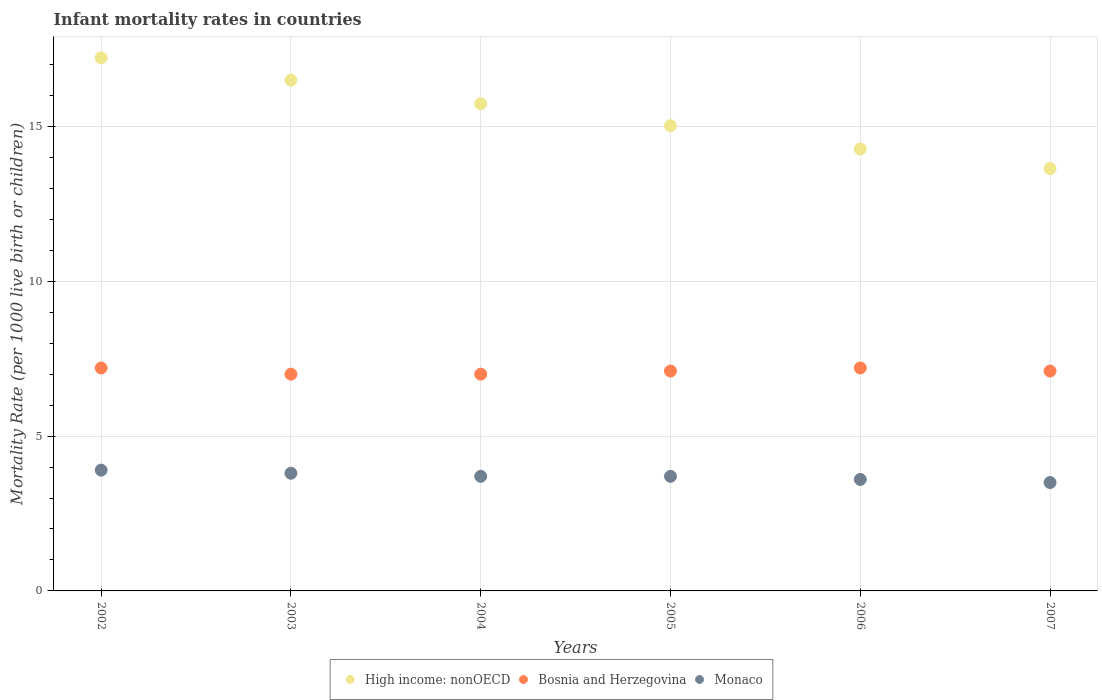What is the infant mortality rate in Bosnia and Herzegovina in 2002?
Offer a very short reply. 7.2. Across all years, what is the minimum infant mortality rate in Bosnia and Herzegovina?
Your response must be concise. 7. In which year was the infant mortality rate in High income: nonOECD maximum?
Give a very brief answer. 2002. In which year was the infant mortality rate in Monaco minimum?
Provide a succinct answer. 2007. What is the total infant mortality rate in High income: nonOECD in the graph?
Your answer should be compact. 92.36. What is the difference between the infant mortality rate in Bosnia and Herzegovina in 2003 and that in 2004?
Ensure brevity in your answer.  0. What is the difference between the infant mortality rate in Monaco in 2003 and the infant mortality rate in Bosnia and Herzegovina in 2007?
Provide a succinct answer. -3.3. What is the average infant mortality rate in Bosnia and Herzegovina per year?
Your answer should be very brief. 7.1. In the year 2005, what is the difference between the infant mortality rate in Bosnia and Herzegovina and infant mortality rate in Monaco?
Offer a very short reply. 3.4. What is the ratio of the infant mortality rate in High income: nonOECD in 2003 to that in 2004?
Ensure brevity in your answer.  1.05. What is the difference between the highest and the second highest infant mortality rate in Monaco?
Make the answer very short. 0.1. What is the difference between the highest and the lowest infant mortality rate in High income: nonOECD?
Your answer should be very brief. 3.58. In how many years, is the infant mortality rate in Monaco greater than the average infant mortality rate in Monaco taken over all years?
Provide a succinct answer. 4. Is the sum of the infant mortality rate in Bosnia and Herzegovina in 2002 and 2004 greater than the maximum infant mortality rate in Monaco across all years?
Make the answer very short. Yes. Does the infant mortality rate in Bosnia and Herzegovina monotonically increase over the years?
Keep it short and to the point. No. How many dotlines are there?
Ensure brevity in your answer.  3. What is the difference between two consecutive major ticks on the Y-axis?
Keep it short and to the point. 5. Are the values on the major ticks of Y-axis written in scientific E-notation?
Make the answer very short. No. Does the graph contain grids?
Offer a terse response. Yes. How many legend labels are there?
Give a very brief answer. 3. What is the title of the graph?
Offer a terse response. Infant mortality rates in countries. Does "Moldova" appear as one of the legend labels in the graph?
Your answer should be very brief. No. What is the label or title of the X-axis?
Give a very brief answer. Years. What is the label or title of the Y-axis?
Offer a terse response. Mortality Rate (per 1000 live birth or children). What is the Mortality Rate (per 1000 live birth or children) of High income: nonOECD in 2002?
Offer a very short reply. 17.21. What is the Mortality Rate (per 1000 live birth or children) of Monaco in 2002?
Your answer should be compact. 3.9. What is the Mortality Rate (per 1000 live birth or children) of High income: nonOECD in 2003?
Offer a very short reply. 16.49. What is the Mortality Rate (per 1000 live birth or children) in Bosnia and Herzegovina in 2003?
Keep it short and to the point. 7. What is the Mortality Rate (per 1000 live birth or children) of High income: nonOECD in 2004?
Make the answer very short. 15.73. What is the Mortality Rate (per 1000 live birth or children) in Bosnia and Herzegovina in 2004?
Offer a terse response. 7. What is the Mortality Rate (per 1000 live birth or children) of Monaco in 2004?
Provide a succinct answer. 3.7. What is the Mortality Rate (per 1000 live birth or children) in High income: nonOECD in 2005?
Make the answer very short. 15.02. What is the Mortality Rate (per 1000 live birth or children) in High income: nonOECD in 2006?
Your response must be concise. 14.27. What is the Mortality Rate (per 1000 live birth or children) in Bosnia and Herzegovina in 2006?
Your response must be concise. 7.2. What is the Mortality Rate (per 1000 live birth or children) of High income: nonOECD in 2007?
Provide a short and direct response. 13.64. What is the Mortality Rate (per 1000 live birth or children) in Monaco in 2007?
Offer a terse response. 3.5. Across all years, what is the maximum Mortality Rate (per 1000 live birth or children) in High income: nonOECD?
Your response must be concise. 17.21. Across all years, what is the maximum Mortality Rate (per 1000 live birth or children) in Monaco?
Keep it short and to the point. 3.9. Across all years, what is the minimum Mortality Rate (per 1000 live birth or children) in High income: nonOECD?
Give a very brief answer. 13.64. Across all years, what is the minimum Mortality Rate (per 1000 live birth or children) of Bosnia and Herzegovina?
Offer a terse response. 7. What is the total Mortality Rate (per 1000 live birth or children) in High income: nonOECD in the graph?
Give a very brief answer. 92.36. What is the total Mortality Rate (per 1000 live birth or children) of Bosnia and Herzegovina in the graph?
Ensure brevity in your answer.  42.6. What is the total Mortality Rate (per 1000 live birth or children) of Monaco in the graph?
Provide a succinct answer. 22.2. What is the difference between the Mortality Rate (per 1000 live birth or children) in High income: nonOECD in 2002 and that in 2003?
Your answer should be very brief. 0.72. What is the difference between the Mortality Rate (per 1000 live birth or children) in High income: nonOECD in 2002 and that in 2004?
Your response must be concise. 1.48. What is the difference between the Mortality Rate (per 1000 live birth or children) of Monaco in 2002 and that in 2004?
Ensure brevity in your answer.  0.2. What is the difference between the Mortality Rate (per 1000 live birth or children) in High income: nonOECD in 2002 and that in 2005?
Your response must be concise. 2.2. What is the difference between the Mortality Rate (per 1000 live birth or children) of Bosnia and Herzegovina in 2002 and that in 2005?
Offer a very short reply. 0.1. What is the difference between the Mortality Rate (per 1000 live birth or children) of High income: nonOECD in 2002 and that in 2006?
Keep it short and to the point. 2.95. What is the difference between the Mortality Rate (per 1000 live birth or children) of Monaco in 2002 and that in 2006?
Give a very brief answer. 0.3. What is the difference between the Mortality Rate (per 1000 live birth or children) of High income: nonOECD in 2002 and that in 2007?
Give a very brief answer. 3.58. What is the difference between the Mortality Rate (per 1000 live birth or children) of Bosnia and Herzegovina in 2002 and that in 2007?
Provide a succinct answer. 0.1. What is the difference between the Mortality Rate (per 1000 live birth or children) of High income: nonOECD in 2003 and that in 2004?
Give a very brief answer. 0.76. What is the difference between the Mortality Rate (per 1000 live birth or children) in Monaco in 2003 and that in 2004?
Provide a succinct answer. 0.1. What is the difference between the Mortality Rate (per 1000 live birth or children) of High income: nonOECD in 2003 and that in 2005?
Keep it short and to the point. 1.47. What is the difference between the Mortality Rate (per 1000 live birth or children) in Bosnia and Herzegovina in 2003 and that in 2005?
Provide a succinct answer. -0.1. What is the difference between the Mortality Rate (per 1000 live birth or children) in High income: nonOECD in 2003 and that in 2006?
Your answer should be very brief. 2.23. What is the difference between the Mortality Rate (per 1000 live birth or children) of Bosnia and Herzegovina in 2003 and that in 2006?
Ensure brevity in your answer.  -0.2. What is the difference between the Mortality Rate (per 1000 live birth or children) in High income: nonOECD in 2003 and that in 2007?
Your response must be concise. 2.85. What is the difference between the Mortality Rate (per 1000 live birth or children) of High income: nonOECD in 2004 and that in 2005?
Provide a succinct answer. 0.71. What is the difference between the Mortality Rate (per 1000 live birth or children) of Bosnia and Herzegovina in 2004 and that in 2005?
Your answer should be very brief. -0.1. What is the difference between the Mortality Rate (per 1000 live birth or children) in Monaco in 2004 and that in 2005?
Keep it short and to the point. 0. What is the difference between the Mortality Rate (per 1000 live birth or children) in High income: nonOECD in 2004 and that in 2006?
Ensure brevity in your answer.  1.46. What is the difference between the Mortality Rate (per 1000 live birth or children) in Monaco in 2004 and that in 2006?
Your answer should be compact. 0.1. What is the difference between the Mortality Rate (per 1000 live birth or children) of High income: nonOECD in 2004 and that in 2007?
Offer a terse response. 2.09. What is the difference between the Mortality Rate (per 1000 live birth or children) in Monaco in 2004 and that in 2007?
Provide a succinct answer. 0.2. What is the difference between the Mortality Rate (per 1000 live birth or children) of High income: nonOECD in 2005 and that in 2006?
Make the answer very short. 0.75. What is the difference between the Mortality Rate (per 1000 live birth or children) of Bosnia and Herzegovina in 2005 and that in 2006?
Offer a very short reply. -0.1. What is the difference between the Mortality Rate (per 1000 live birth or children) in Monaco in 2005 and that in 2006?
Your answer should be very brief. 0.1. What is the difference between the Mortality Rate (per 1000 live birth or children) of High income: nonOECD in 2005 and that in 2007?
Provide a succinct answer. 1.38. What is the difference between the Mortality Rate (per 1000 live birth or children) of Bosnia and Herzegovina in 2005 and that in 2007?
Your answer should be compact. 0. What is the difference between the Mortality Rate (per 1000 live birth or children) in Monaco in 2005 and that in 2007?
Make the answer very short. 0.2. What is the difference between the Mortality Rate (per 1000 live birth or children) in High income: nonOECD in 2006 and that in 2007?
Keep it short and to the point. 0.63. What is the difference between the Mortality Rate (per 1000 live birth or children) of High income: nonOECD in 2002 and the Mortality Rate (per 1000 live birth or children) of Bosnia and Herzegovina in 2003?
Offer a terse response. 10.21. What is the difference between the Mortality Rate (per 1000 live birth or children) in High income: nonOECD in 2002 and the Mortality Rate (per 1000 live birth or children) in Monaco in 2003?
Keep it short and to the point. 13.41. What is the difference between the Mortality Rate (per 1000 live birth or children) of High income: nonOECD in 2002 and the Mortality Rate (per 1000 live birth or children) of Bosnia and Herzegovina in 2004?
Keep it short and to the point. 10.21. What is the difference between the Mortality Rate (per 1000 live birth or children) of High income: nonOECD in 2002 and the Mortality Rate (per 1000 live birth or children) of Monaco in 2004?
Your answer should be compact. 13.51. What is the difference between the Mortality Rate (per 1000 live birth or children) in Bosnia and Herzegovina in 2002 and the Mortality Rate (per 1000 live birth or children) in Monaco in 2004?
Give a very brief answer. 3.5. What is the difference between the Mortality Rate (per 1000 live birth or children) in High income: nonOECD in 2002 and the Mortality Rate (per 1000 live birth or children) in Bosnia and Herzegovina in 2005?
Provide a short and direct response. 10.11. What is the difference between the Mortality Rate (per 1000 live birth or children) in High income: nonOECD in 2002 and the Mortality Rate (per 1000 live birth or children) in Monaco in 2005?
Your answer should be compact. 13.51. What is the difference between the Mortality Rate (per 1000 live birth or children) in High income: nonOECD in 2002 and the Mortality Rate (per 1000 live birth or children) in Bosnia and Herzegovina in 2006?
Ensure brevity in your answer.  10.01. What is the difference between the Mortality Rate (per 1000 live birth or children) in High income: nonOECD in 2002 and the Mortality Rate (per 1000 live birth or children) in Monaco in 2006?
Offer a very short reply. 13.61. What is the difference between the Mortality Rate (per 1000 live birth or children) of High income: nonOECD in 2002 and the Mortality Rate (per 1000 live birth or children) of Bosnia and Herzegovina in 2007?
Keep it short and to the point. 10.11. What is the difference between the Mortality Rate (per 1000 live birth or children) of High income: nonOECD in 2002 and the Mortality Rate (per 1000 live birth or children) of Monaco in 2007?
Keep it short and to the point. 13.71. What is the difference between the Mortality Rate (per 1000 live birth or children) in High income: nonOECD in 2003 and the Mortality Rate (per 1000 live birth or children) in Bosnia and Herzegovina in 2004?
Keep it short and to the point. 9.49. What is the difference between the Mortality Rate (per 1000 live birth or children) of High income: nonOECD in 2003 and the Mortality Rate (per 1000 live birth or children) of Monaco in 2004?
Your response must be concise. 12.79. What is the difference between the Mortality Rate (per 1000 live birth or children) in High income: nonOECD in 2003 and the Mortality Rate (per 1000 live birth or children) in Bosnia and Herzegovina in 2005?
Ensure brevity in your answer.  9.39. What is the difference between the Mortality Rate (per 1000 live birth or children) in High income: nonOECD in 2003 and the Mortality Rate (per 1000 live birth or children) in Monaco in 2005?
Your answer should be very brief. 12.79. What is the difference between the Mortality Rate (per 1000 live birth or children) in Bosnia and Herzegovina in 2003 and the Mortality Rate (per 1000 live birth or children) in Monaco in 2005?
Ensure brevity in your answer.  3.3. What is the difference between the Mortality Rate (per 1000 live birth or children) of High income: nonOECD in 2003 and the Mortality Rate (per 1000 live birth or children) of Bosnia and Herzegovina in 2006?
Offer a very short reply. 9.29. What is the difference between the Mortality Rate (per 1000 live birth or children) in High income: nonOECD in 2003 and the Mortality Rate (per 1000 live birth or children) in Monaco in 2006?
Your answer should be compact. 12.89. What is the difference between the Mortality Rate (per 1000 live birth or children) of Bosnia and Herzegovina in 2003 and the Mortality Rate (per 1000 live birth or children) of Monaco in 2006?
Offer a very short reply. 3.4. What is the difference between the Mortality Rate (per 1000 live birth or children) in High income: nonOECD in 2003 and the Mortality Rate (per 1000 live birth or children) in Bosnia and Herzegovina in 2007?
Your answer should be very brief. 9.39. What is the difference between the Mortality Rate (per 1000 live birth or children) in High income: nonOECD in 2003 and the Mortality Rate (per 1000 live birth or children) in Monaco in 2007?
Offer a very short reply. 12.99. What is the difference between the Mortality Rate (per 1000 live birth or children) in High income: nonOECD in 2004 and the Mortality Rate (per 1000 live birth or children) in Bosnia and Herzegovina in 2005?
Your answer should be compact. 8.63. What is the difference between the Mortality Rate (per 1000 live birth or children) in High income: nonOECD in 2004 and the Mortality Rate (per 1000 live birth or children) in Monaco in 2005?
Provide a short and direct response. 12.03. What is the difference between the Mortality Rate (per 1000 live birth or children) in Bosnia and Herzegovina in 2004 and the Mortality Rate (per 1000 live birth or children) in Monaco in 2005?
Provide a succinct answer. 3.3. What is the difference between the Mortality Rate (per 1000 live birth or children) in High income: nonOECD in 2004 and the Mortality Rate (per 1000 live birth or children) in Bosnia and Herzegovina in 2006?
Ensure brevity in your answer.  8.53. What is the difference between the Mortality Rate (per 1000 live birth or children) of High income: nonOECD in 2004 and the Mortality Rate (per 1000 live birth or children) of Monaco in 2006?
Ensure brevity in your answer.  12.13. What is the difference between the Mortality Rate (per 1000 live birth or children) in High income: nonOECD in 2004 and the Mortality Rate (per 1000 live birth or children) in Bosnia and Herzegovina in 2007?
Offer a terse response. 8.63. What is the difference between the Mortality Rate (per 1000 live birth or children) in High income: nonOECD in 2004 and the Mortality Rate (per 1000 live birth or children) in Monaco in 2007?
Offer a terse response. 12.23. What is the difference between the Mortality Rate (per 1000 live birth or children) of Bosnia and Herzegovina in 2004 and the Mortality Rate (per 1000 live birth or children) of Monaco in 2007?
Ensure brevity in your answer.  3.5. What is the difference between the Mortality Rate (per 1000 live birth or children) in High income: nonOECD in 2005 and the Mortality Rate (per 1000 live birth or children) in Bosnia and Herzegovina in 2006?
Provide a short and direct response. 7.82. What is the difference between the Mortality Rate (per 1000 live birth or children) in High income: nonOECD in 2005 and the Mortality Rate (per 1000 live birth or children) in Monaco in 2006?
Offer a terse response. 11.42. What is the difference between the Mortality Rate (per 1000 live birth or children) of Bosnia and Herzegovina in 2005 and the Mortality Rate (per 1000 live birth or children) of Monaco in 2006?
Keep it short and to the point. 3.5. What is the difference between the Mortality Rate (per 1000 live birth or children) in High income: nonOECD in 2005 and the Mortality Rate (per 1000 live birth or children) in Bosnia and Herzegovina in 2007?
Your answer should be very brief. 7.92. What is the difference between the Mortality Rate (per 1000 live birth or children) in High income: nonOECD in 2005 and the Mortality Rate (per 1000 live birth or children) in Monaco in 2007?
Make the answer very short. 11.52. What is the difference between the Mortality Rate (per 1000 live birth or children) of Bosnia and Herzegovina in 2005 and the Mortality Rate (per 1000 live birth or children) of Monaco in 2007?
Offer a very short reply. 3.6. What is the difference between the Mortality Rate (per 1000 live birth or children) in High income: nonOECD in 2006 and the Mortality Rate (per 1000 live birth or children) in Bosnia and Herzegovina in 2007?
Offer a very short reply. 7.17. What is the difference between the Mortality Rate (per 1000 live birth or children) in High income: nonOECD in 2006 and the Mortality Rate (per 1000 live birth or children) in Monaco in 2007?
Give a very brief answer. 10.77. What is the difference between the Mortality Rate (per 1000 live birth or children) in Bosnia and Herzegovina in 2006 and the Mortality Rate (per 1000 live birth or children) in Monaco in 2007?
Provide a short and direct response. 3.7. What is the average Mortality Rate (per 1000 live birth or children) of High income: nonOECD per year?
Offer a very short reply. 15.39. What is the average Mortality Rate (per 1000 live birth or children) in Monaco per year?
Offer a very short reply. 3.7. In the year 2002, what is the difference between the Mortality Rate (per 1000 live birth or children) of High income: nonOECD and Mortality Rate (per 1000 live birth or children) of Bosnia and Herzegovina?
Your answer should be very brief. 10.01. In the year 2002, what is the difference between the Mortality Rate (per 1000 live birth or children) of High income: nonOECD and Mortality Rate (per 1000 live birth or children) of Monaco?
Provide a short and direct response. 13.31. In the year 2002, what is the difference between the Mortality Rate (per 1000 live birth or children) of Bosnia and Herzegovina and Mortality Rate (per 1000 live birth or children) of Monaco?
Offer a very short reply. 3.3. In the year 2003, what is the difference between the Mortality Rate (per 1000 live birth or children) in High income: nonOECD and Mortality Rate (per 1000 live birth or children) in Bosnia and Herzegovina?
Ensure brevity in your answer.  9.49. In the year 2003, what is the difference between the Mortality Rate (per 1000 live birth or children) in High income: nonOECD and Mortality Rate (per 1000 live birth or children) in Monaco?
Ensure brevity in your answer.  12.69. In the year 2003, what is the difference between the Mortality Rate (per 1000 live birth or children) in Bosnia and Herzegovina and Mortality Rate (per 1000 live birth or children) in Monaco?
Your answer should be very brief. 3.2. In the year 2004, what is the difference between the Mortality Rate (per 1000 live birth or children) in High income: nonOECD and Mortality Rate (per 1000 live birth or children) in Bosnia and Herzegovina?
Ensure brevity in your answer.  8.73. In the year 2004, what is the difference between the Mortality Rate (per 1000 live birth or children) in High income: nonOECD and Mortality Rate (per 1000 live birth or children) in Monaco?
Your response must be concise. 12.03. In the year 2004, what is the difference between the Mortality Rate (per 1000 live birth or children) in Bosnia and Herzegovina and Mortality Rate (per 1000 live birth or children) in Monaco?
Keep it short and to the point. 3.3. In the year 2005, what is the difference between the Mortality Rate (per 1000 live birth or children) in High income: nonOECD and Mortality Rate (per 1000 live birth or children) in Bosnia and Herzegovina?
Provide a short and direct response. 7.92. In the year 2005, what is the difference between the Mortality Rate (per 1000 live birth or children) in High income: nonOECD and Mortality Rate (per 1000 live birth or children) in Monaco?
Offer a very short reply. 11.32. In the year 2006, what is the difference between the Mortality Rate (per 1000 live birth or children) in High income: nonOECD and Mortality Rate (per 1000 live birth or children) in Bosnia and Herzegovina?
Keep it short and to the point. 7.07. In the year 2006, what is the difference between the Mortality Rate (per 1000 live birth or children) in High income: nonOECD and Mortality Rate (per 1000 live birth or children) in Monaco?
Your response must be concise. 10.67. In the year 2006, what is the difference between the Mortality Rate (per 1000 live birth or children) in Bosnia and Herzegovina and Mortality Rate (per 1000 live birth or children) in Monaco?
Provide a succinct answer. 3.6. In the year 2007, what is the difference between the Mortality Rate (per 1000 live birth or children) of High income: nonOECD and Mortality Rate (per 1000 live birth or children) of Bosnia and Herzegovina?
Offer a terse response. 6.54. In the year 2007, what is the difference between the Mortality Rate (per 1000 live birth or children) of High income: nonOECD and Mortality Rate (per 1000 live birth or children) of Monaco?
Ensure brevity in your answer.  10.14. In the year 2007, what is the difference between the Mortality Rate (per 1000 live birth or children) of Bosnia and Herzegovina and Mortality Rate (per 1000 live birth or children) of Monaco?
Keep it short and to the point. 3.6. What is the ratio of the Mortality Rate (per 1000 live birth or children) in High income: nonOECD in 2002 to that in 2003?
Give a very brief answer. 1.04. What is the ratio of the Mortality Rate (per 1000 live birth or children) of Bosnia and Herzegovina in 2002 to that in 2003?
Provide a succinct answer. 1.03. What is the ratio of the Mortality Rate (per 1000 live birth or children) of Monaco in 2002 to that in 2003?
Your answer should be very brief. 1.03. What is the ratio of the Mortality Rate (per 1000 live birth or children) in High income: nonOECD in 2002 to that in 2004?
Provide a short and direct response. 1.09. What is the ratio of the Mortality Rate (per 1000 live birth or children) in Bosnia and Herzegovina in 2002 to that in 2004?
Offer a terse response. 1.03. What is the ratio of the Mortality Rate (per 1000 live birth or children) in Monaco in 2002 to that in 2004?
Your response must be concise. 1.05. What is the ratio of the Mortality Rate (per 1000 live birth or children) in High income: nonOECD in 2002 to that in 2005?
Provide a short and direct response. 1.15. What is the ratio of the Mortality Rate (per 1000 live birth or children) of Bosnia and Herzegovina in 2002 to that in 2005?
Provide a succinct answer. 1.01. What is the ratio of the Mortality Rate (per 1000 live birth or children) of Monaco in 2002 to that in 2005?
Keep it short and to the point. 1.05. What is the ratio of the Mortality Rate (per 1000 live birth or children) of High income: nonOECD in 2002 to that in 2006?
Offer a terse response. 1.21. What is the ratio of the Mortality Rate (per 1000 live birth or children) of Monaco in 2002 to that in 2006?
Make the answer very short. 1.08. What is the ratio of the Mortality Rate (per 1000 live birth or children) in High income: nonOECD in 2002 to that in 2007?
Ensure brevity in your answer.  1.26. What is the ratio of the Mortality Rate (per 1000 live birth or children) of Bosnia and Herzegovina in 2002 to that in 2007?
Provide a succinct answer. 1.01. What is the ratio of the Mortality Rate (per 1000 live birth or children) in Monaco in 2002 to that in 2007?
Your response must be concise. 1.11. What is the ratio of the Mortality Rate (per 1000 live birth or children) of High income: nonOECD in 2003 to that in 2004?
Make the answer very short. 1.05. What is the ratio of the Mortality Rate (per 1000 live birth or children) in High income: nonOECD in 2003 to that in 2005?
Offer a very short reply. 1.1. What is the ratio of the Mortality Rate (per 1000 live birth or children) of Bosnia and Herzegovina in 2003 to that in 2005?
Offer a terse response. 0.99. What is the ratio of the Mortality Rate (per 1000 live birth or children) in High income: nonOECD in 2003 to that in 2006?
Provide a short and direct response. 1.16. What is the ratio of the Mortality Rate (per 1000 live birth or children) of Bosnia and Herzegovina in 2003 to that in 2006?
Ensure brevity in your answer.  0.97. What is the ratio of the Mortality Rate (per 1000 live birth or children) in Monaco in 2003 to that in 2006?
Your answer should be compact. 1.06. What is the ratio of the Mortality Rate (per 1000 live birth or children) of High income: nonOECD in 2003 to that in 2007?
Offer a very short reply. 1.21. What is the ratio of the Mortality Rate (per 1000 live birth or children) of Bosnia and Herzegovina in 2003 to that in 2007?
Give a very brief answer. 0.99. What is the ratio of the Mortality Rate (per 1000 live birth or children) of Monaco in 2003 to that in 2007?
Provide a succinct answer. 1.09. What is the ratio of the Mortality Rate (per 1000 live birth or children) in High income: nonOECD in 2004 to that in 2005?
Ensure brevity in your answer.  1.05. What is the ratio of the Mortality Rate (per 1000 live birth or children) of Bosnia and Herzegovina in 2004 to that in 2005?
Your answer should be very brief. 0.99. What is the ratio of the Mortality Rate (per 1000 live birth or children) of Monaco in 2004 to that in 2005?
Your answer should be very brief. 1. What is the ratio of the Mortality Rate (per 1000 live birth or children) of High income: nonOECD in 2004 to that in 2006?
Your answer should be compact. 1.1. What is the ratio of the Mortality Rate (per 1000 live birth or children) of Bosnia and Herzegovina in 2004 to that in 2006?
Offer a very short reply. 0.97. What is the ratio of the Mortality Rate (per 1000 live birth or children) of Monaco in 2004 to that in 2006?
Ensure brevity in your answer.  1.03. What is the ratio of the Mortality Rate (per 1000 live birth or children) of High income: nonOECD in 2004 to that in 2007?
Provide a succinct answer. 1.15. What is the ratio of the Mortality Rate (per 1000 live birth or children) of Bosnia and Herzegovina in 2004 to that in 2007?
Give a very brief answer. 0.99. What is the ratio of the Mortality Rate (per 1000 live birth or children) of Monaco in 2004 to that in 2007?
Ensure brevity in your answer.  1.06. What is the ratio of the Mortality Rate (per 1000 live birth or children) in High income: nonOECD in 2005 to that in 2006?
Give a very brief answer. 1.05. What is the ratio of the Mortality Rate (per 1000 live birth or children) of Bosnia and Herzegovina in 2005 to that in 2006?
Keep it short and to the point. 0.99. What is the ratio of the Mortality Rate (per 1000 live birth or children) of Monaco in 2005 to that in 2006?
Ensure brevity in your answer.  1.03. What is the ratio of the Mortality Rate (per 1000 live birth or children) of High income: nonOECD in 2005 to that in 2007?
Your response must be concise. 1.1. What is the ratio of the Mortality Rate (per 1000 live birth or children) of Bosnia and Herzegovina in 2005 to that in 2007?
Your response must be concise. 1. What is the ratio of the Mortality Rate (per 1000 live birth or children) in Monaco in 2005 to that in 2007?
Your answer should be very brief. 1.06. What is the ratio of the Mortality Rate (per 1000 live birth or children) in High income: nonOECD in 2006 to that in 2007?
Ensure brevity in your answer.  1.05. What is the ratio of the Mortality Rate (per 1000 live birth or children) of Bosnia and Herzegovina in 2006 to that in 2007?
Make the answer very short. 1.01. What is the ratio of the Mortality Rate (per 1000 live birth or children) in Monaco in 2006 to that in 2007?
Your response must be concise. 1.03. What is the difference between the highest and the second highest Mortality Rate (per 1000 live birth or children) in High income: nonOECD?
Offer a very short reply. 0.72. What is the difference between the highest and the second highest Mortality Rate (per 1000 live birth or children) of Monaco?
Your response must be concise. 0.1. What is the difference between the highest and the lowest Mortality Rate (per 1000 live birth or children) of High income: nonOECD?
Give a very brief answer. 3.58. What is the difference between the highest and the lowest Mortality Rate (per 1000 live birth or children) in Bosnia and Herzegovina?
Your answer should be very brief. 0.2. 